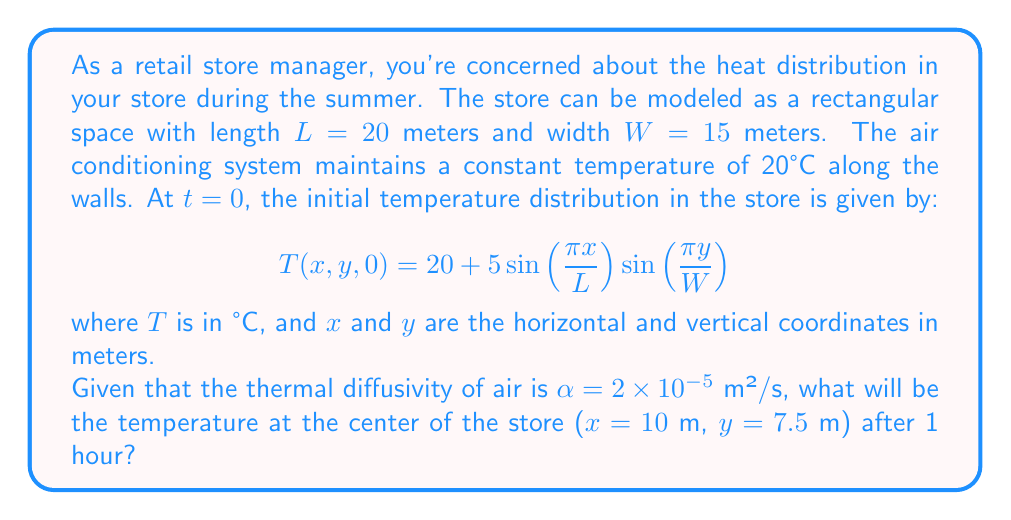Provide a solution to this math problem. To solve this problem, we need to use the 2D heat equation:

$$\frac{\partial T}{\partial t} = \alpha(\frac{\partial^2 T}{\partial x^2} + \frac{\partial^2 T}{\partial y^2})$$

The solution to this equation, given the initial conditions and boundary conditions (constant temperature at the walls), can be expressed as:

$$T(x,y,t) = 20 + 5\sin(\frac{\pi x}{L})\sin(\frac{\pi y}{W})e^{-\alpha t(\frac{\pi^2}{L^2}+\frac{\pi^2}{W^2})}$$

To find the temperature at the center of the store after 1 hour, we need to evaluate this function at x = 10 m, y = 7.5 m, and t = 3600 s (1 hour = 3600 seconds).

Let's calculate step by step:

1) First, calculate the exponent:
   $$-\alpha t(\frac{\pi^2}{L^2}+\frac{\pi^2}{W^2}) = -(2 \times 10^{-5})(3600)(\frac{\pi^2}{20^2}+\frac{\pi^2}{15^2})$$
   $$= -0.072(0.0247 + 0.0439) = -0.0494$$

2) Now, let's evaluate the sine terms:
   $$\sin(\frac{\pi x}{L}) = \sin(\frac{\pi 10}{20}) = \sin(\frac{\pi}{2}) = 1$$
   $$\sin(\frac{\pi y}{W}) = \sin(\frac{\pi 7.5}{15}) = \sin(\frac{\pi}{2}) = 1$$

3) Putting it all together:
   $$T(10,7.5,3600) = 20 + 5(1)(1)e^{-0.0494}$$
   $$= 20 + 5e^{-0.0494}$$
   $$= 20 + 5(0.9518)$$
   $$= 20 + 4.759$$
   $$= 24.759°C$$
Answer: The temperature at the center of the store after 1 hour will be approximately 24.76°C. 